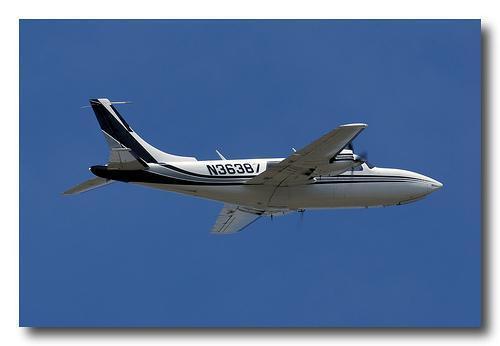How many planes?
Give a very brief answer. 1. 